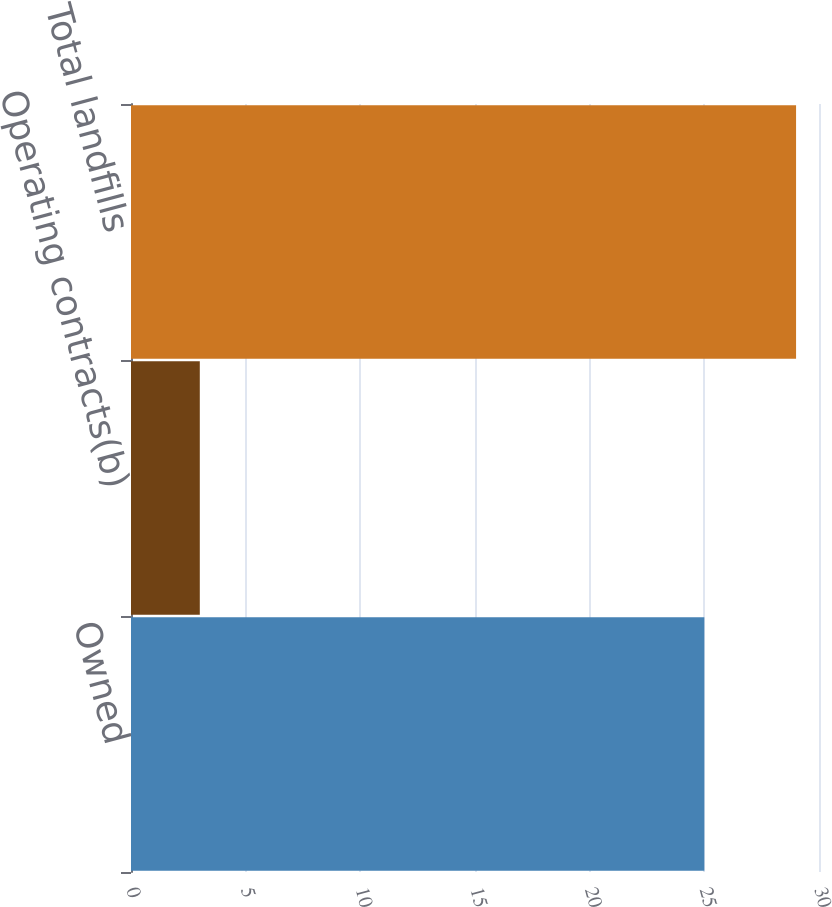Convert chart. <chart><loc_0><loc_0><loc_500><loc_500><bar_chart><fcel>Owned<fcel>Operating contracts(b)<fcel>Total landfills<nl><fcel>25<fcel>3<fcel>29<nl></chart> 